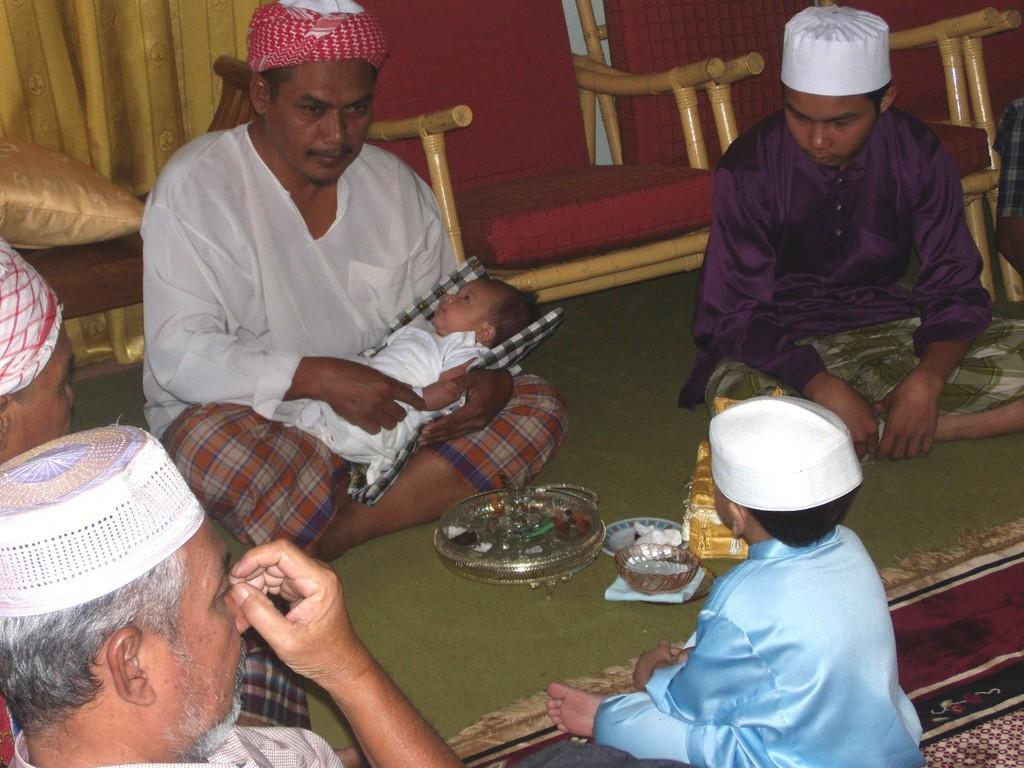What are the people in the image doing? The people in the image are sitting on the floor. What can be seen in the background of the image? There are chairs in the background of the image. What type of clothing or accessory are the people wearing on their heads? All the people are wearing caps on their heads. How does the growth of the bear affect the cart in the image? There is no bear or cart present in the image, so this question cannot be answered. 